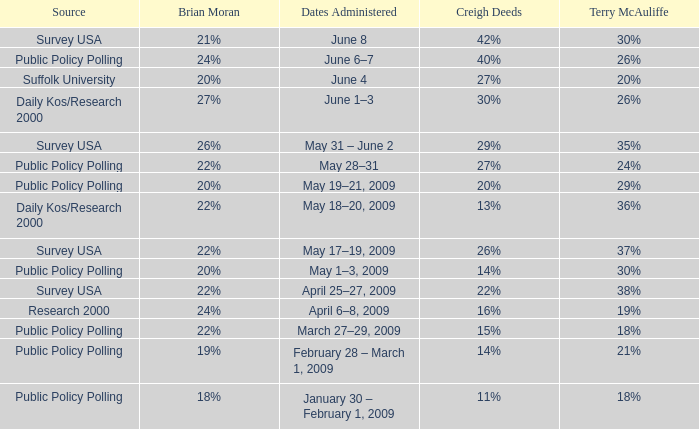Which Terry McAuliffe is it that has a Dates Administered on June 6–7? 26%. 